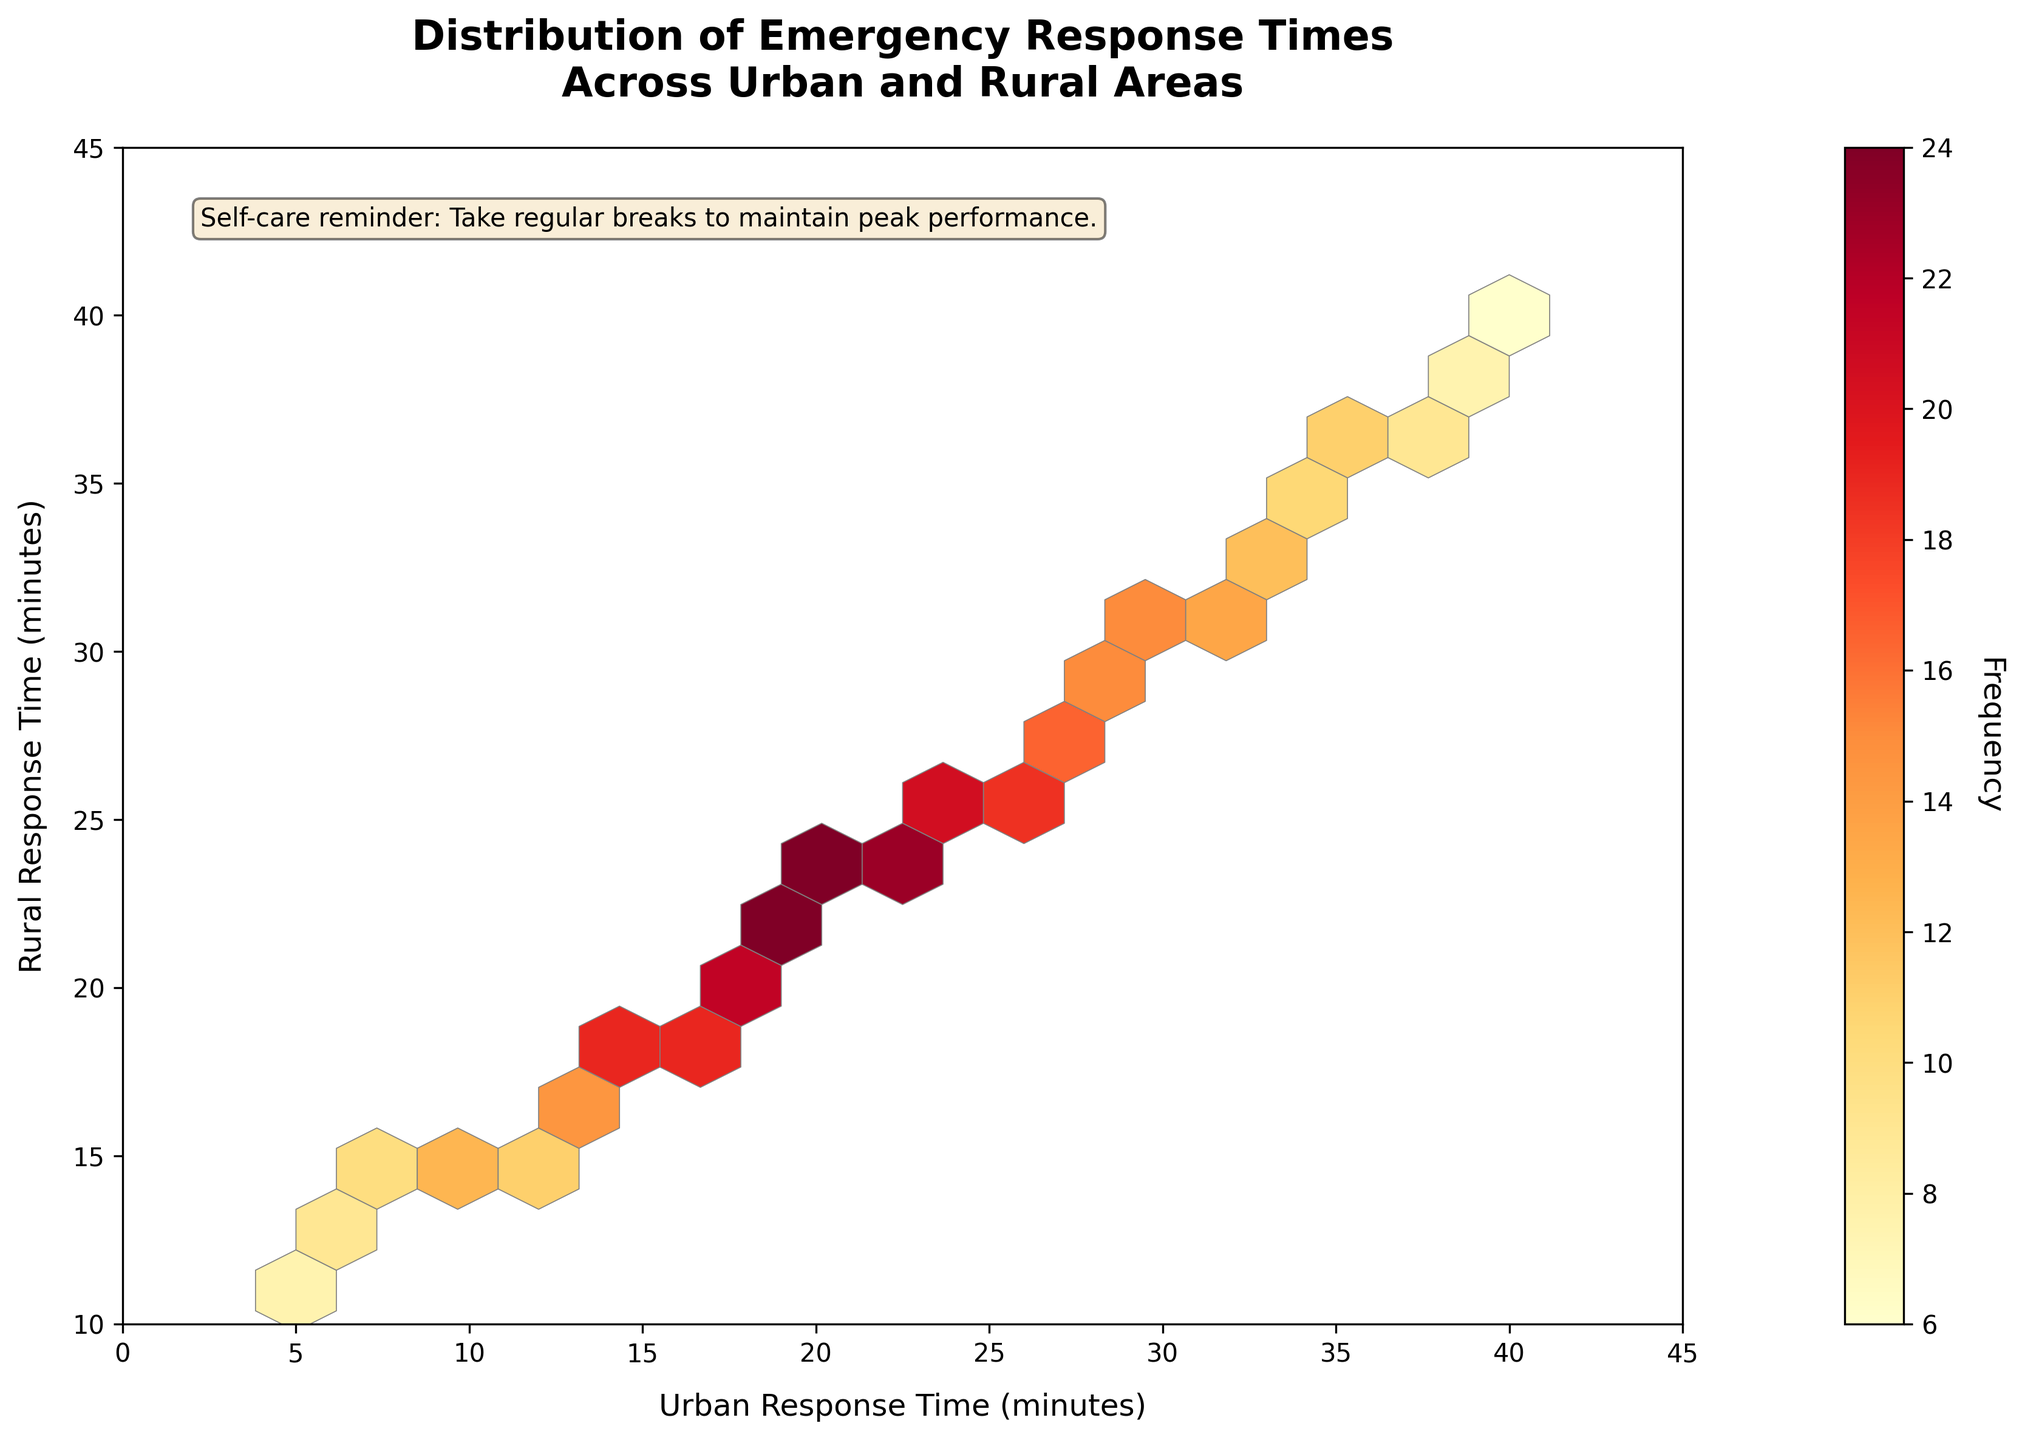What does the title of the hexbin plot describe? The title at the top of the hexbin plot describes the distribution of emergency response times across urban and rural areas. This indicates that the plot provides a comparison between the response times in urban and rural settings.
Answer: Distribution of Emergency Response Times Across Urban and Rural Areas What are the labels for the x-axis and y-axis? The x-axis is labeled "Urban Response Time (minutes)" and the y-axis is labeled "Rural Response Time (minutes)." This indicates that the plot uses these axes to compare response times in minutes between urban and rural areas.
Answer: Urban Response Time (minutes) and Rural Response Time (minutes) What does the color bar represent in the hexbin plot? The color bar located to the right of the plot represents the frequency of the data points. The varying colors indicate the density or frequency of data points in each hexbin.
Answer: Frequency Which range of urban response times shows the highest frequency of emergency responses? By looking at the darkest colored hexagon on the plot, which indicates the highest frequency, it appears in the range where urban response time is around 20 to 25 minutes.
Answer: 20 to 25 minutes Are there more data points in the hexagons with lower urban and rural response times or higher response times? Observing the density of the hexagons in the plot, we see that there are more densely colored hexagons in the lower ranges of both urban and rural response times. This suggests a higher frequency of responses is concentrated in the lower response times.
Answer: Lower response times What is the grid size of the hexagons used in the hexbin plot? The grid size of the hexagons is defined by how many hexagons the plot is divided into. According to the plot specifics, the grid size is 15, meaning there are 15 bins along the axis.
Answer: 15 Which region shows a higher density of data points, urban or rural response times? Since the plot uses color intensity to represent density, the regions with darker shades indicate higher densities. The darker shades appear more towards the center of the plot, implying similar densities for both urban and rural response times within specific ranges.
Answer: Similar densities in center ranges What is the frequency range indicated by the color bar? The color bar indicates the range of frequencies represented in the plot. By examining the bar closely, it ranges from the lightest shade (lowest frequency) to the darkest shade (highest frequency).
Answer: 5 to 25 What kind of relationship or pattern can be observed between urban and rural response times? The hexbin plot shows a tendency where both urban and rural response times increase together, as most data points (hexagons) form a diagonal pattern. This suggests a positive correlation between the two.
Answer: Positive correlation How can emergency responders use this plot for improving response times in both urban and rural areas? Emergency responders can identify clusters of high-frequency response times to target areas for improvement. The diagonal pattern indicates both urban and rural areas experience delays simultaneously, suggesting a need for resources or strategy optimization in these time ranges.
Answer: Identify and target high-frequency response clusters for optimization 